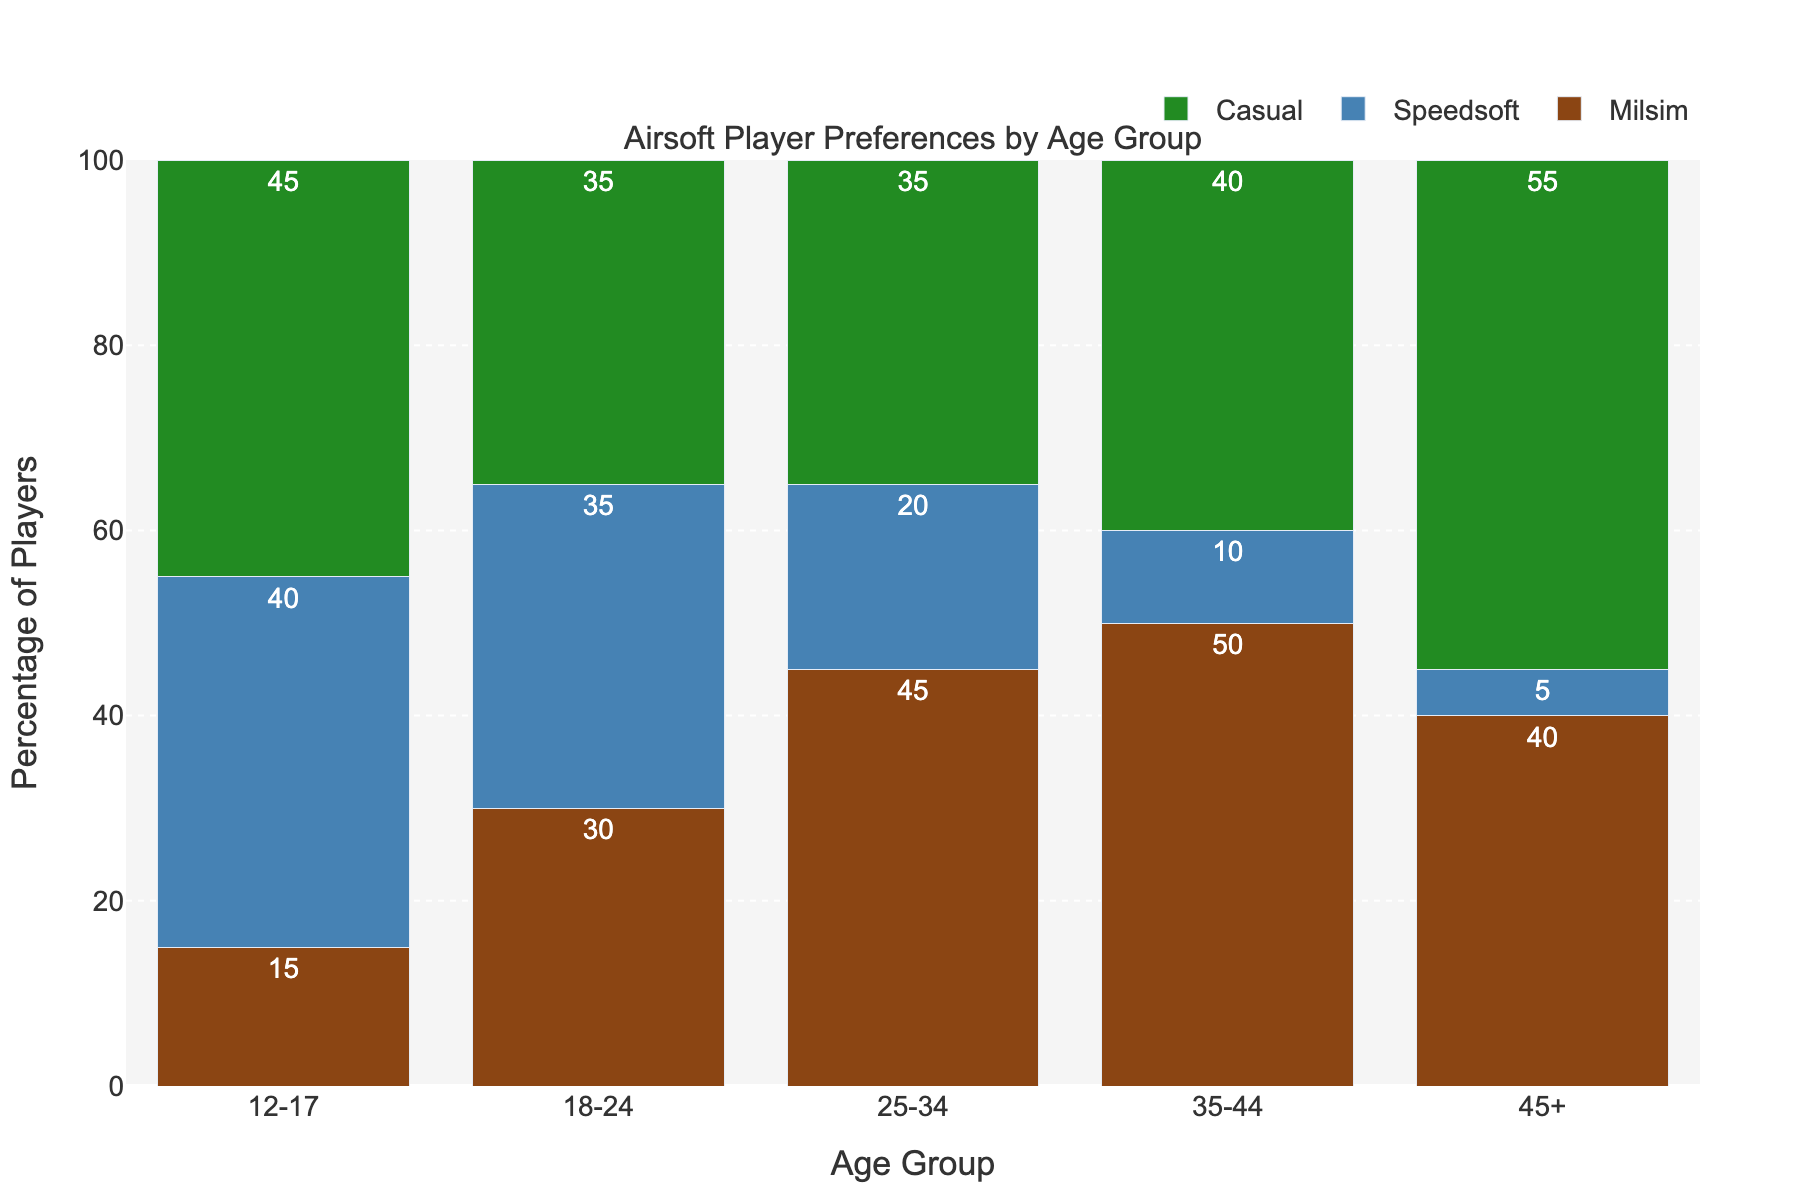What age group has the highest percentage of players preferring Milsim? Looking at the bars for all age groups, the age group 35-44 has the tallest bar in the Milsim category.
Answer: 35-44 Which play style is least preferred by the 45+ age group? Observing the bars for the 45+ age group, the Speedsoft bar is the shortest.
Answer: Speedsoft What is the average percentage of players preferring Casual in the age groups 12-17 and 18-24? The percentages are 45% for 12-17 and 35% for 18-24. The average = (45+35) / 2 = 40%.
Answer: 40% Which age group shows the highest percentage for Casual play style preference? Inspecting the bars for Casual across all age groups, the 45+ age group has the highest bar.
Answer: 45+ For the age group 25-34, what is the combined percentage for Milsim and Speedsoft preferences? The percentages are 45% for Milsim and 20% for Speedsoft. The combined percentage = 45% + 20% = 65%.
Answer: 65% How does the percentage of players preferring Speedsoft in the age group 18-24 compare to those preferring Milsim in the same age group? The Speedsoft preference is 35%, and the Milsim preference is 30%. Speedsoft is higher by 5%.
Answer: Speedsoft is higher by 5% Which color represents the Casual play style preference in the chart? The bar color representing Casual is green.
Answer: Green What is the total percentage of all preferred play styles for the age group 35-44? For 35-44: Milsim (50%), Speedsoft (10%), Casual (40%). Total = 50% + 10% + 40% = 100%.
Answer: 100% In the age group 18-24, which play styles have an equal percentage of preference? Both Speedsoft and Casual have 35% each in the 18-24 age group.
Answer: Speedsoft and Casual 